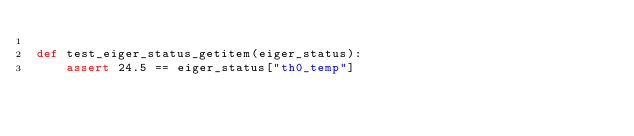<code> <loc_0><loc_0><loc_500><loc_500><_Python_>
def test_eiger_status_getitem(eiger_status):
    assert 24.5 == eiger_status["th0_temp"]
</code> 